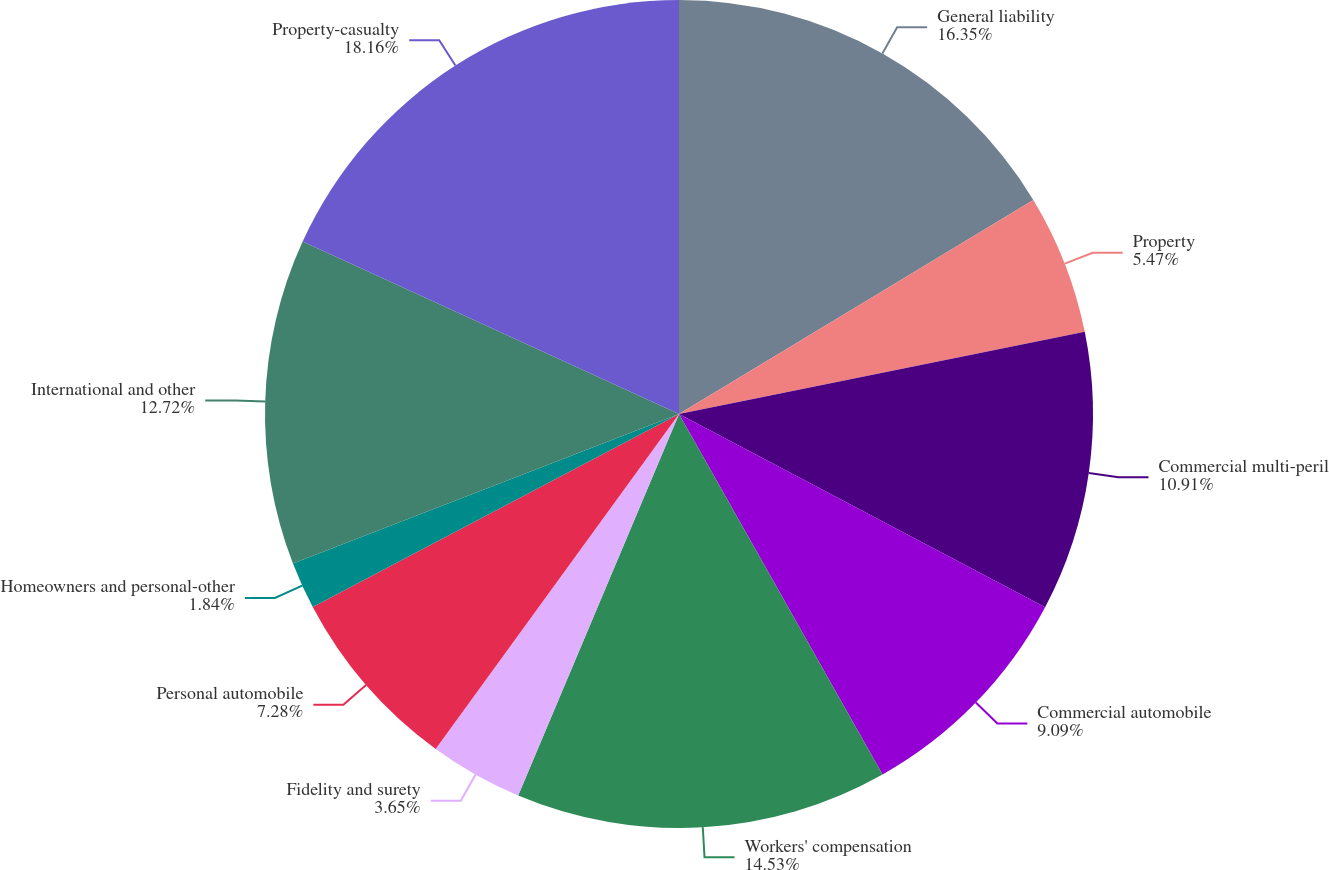Convert chart. <chart><loc_0><loc_0><loc_500><loc_500><pie_chart><fcel>General liability<fcel>Property<fcel>Commercial multi-peril<fcel>Commercial automobile<fcel>Workers' compensation<fcel>Fidelity and surety<fcel>Personal automobile<fcel>Homeowners and personal-other<fcel>International and other<fcel>Property-casualty<nl><fcel>16.35%<fcel>5.47%<fcel>10.91%<fcel>9.09%<fcel>14.53%<fcel>3.65%<fcel>7.28%<fcel>1.84%<fcel>12.72%<fcel>18.16%<nl></chart> 